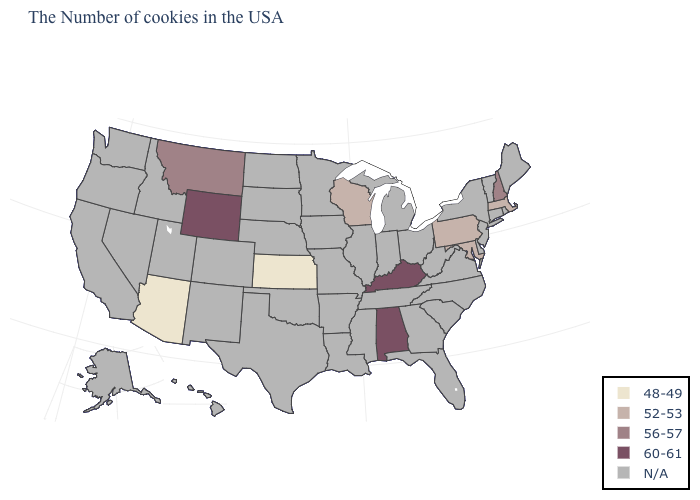Name the states that have a value in the range 52-53?
Answer briefly. Massachusetts, Maryland, Pennsylvania, Wisconsin. Name the states that have a value in the range 48-49?
Concise answer only. Kansas, Arizona. What is the value of Texas?
Quick response, please. N/A. Does Maryland have the highest value in the South?
Be succinct. No. Name the states that have a value in the range 56-57?
Keep it brief. New Hampshire, Montana. What is the value of Missouri?
Be succinct. N/A. Does Wisconsin have the lowest value in the MidWest?
Be succinct. No. What is the value of South Carolina?
Keep it brief. N/A. What is the highest value in the MidWest ?
Answer briefly. 52-53. Which states have the highest value in the USA?
Concise answer only. Kentucky, Alabama, Wyoming. Name the states that have a value in the range 56-57?
Answer briefly. New Hampshire, Montana. What is the lowest value in the USA?
Write a very short answer. 48-49. 